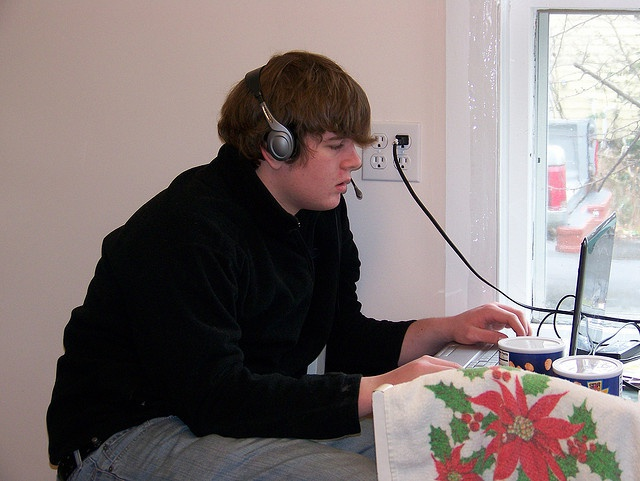Describe the objects in this image and their specific colors. I can see people in gray, black, brown, and maroon tones, laptop in gray, darkgray, and lightgray tones, and cup in gray, white, navy, and darkgray tones in this image. 